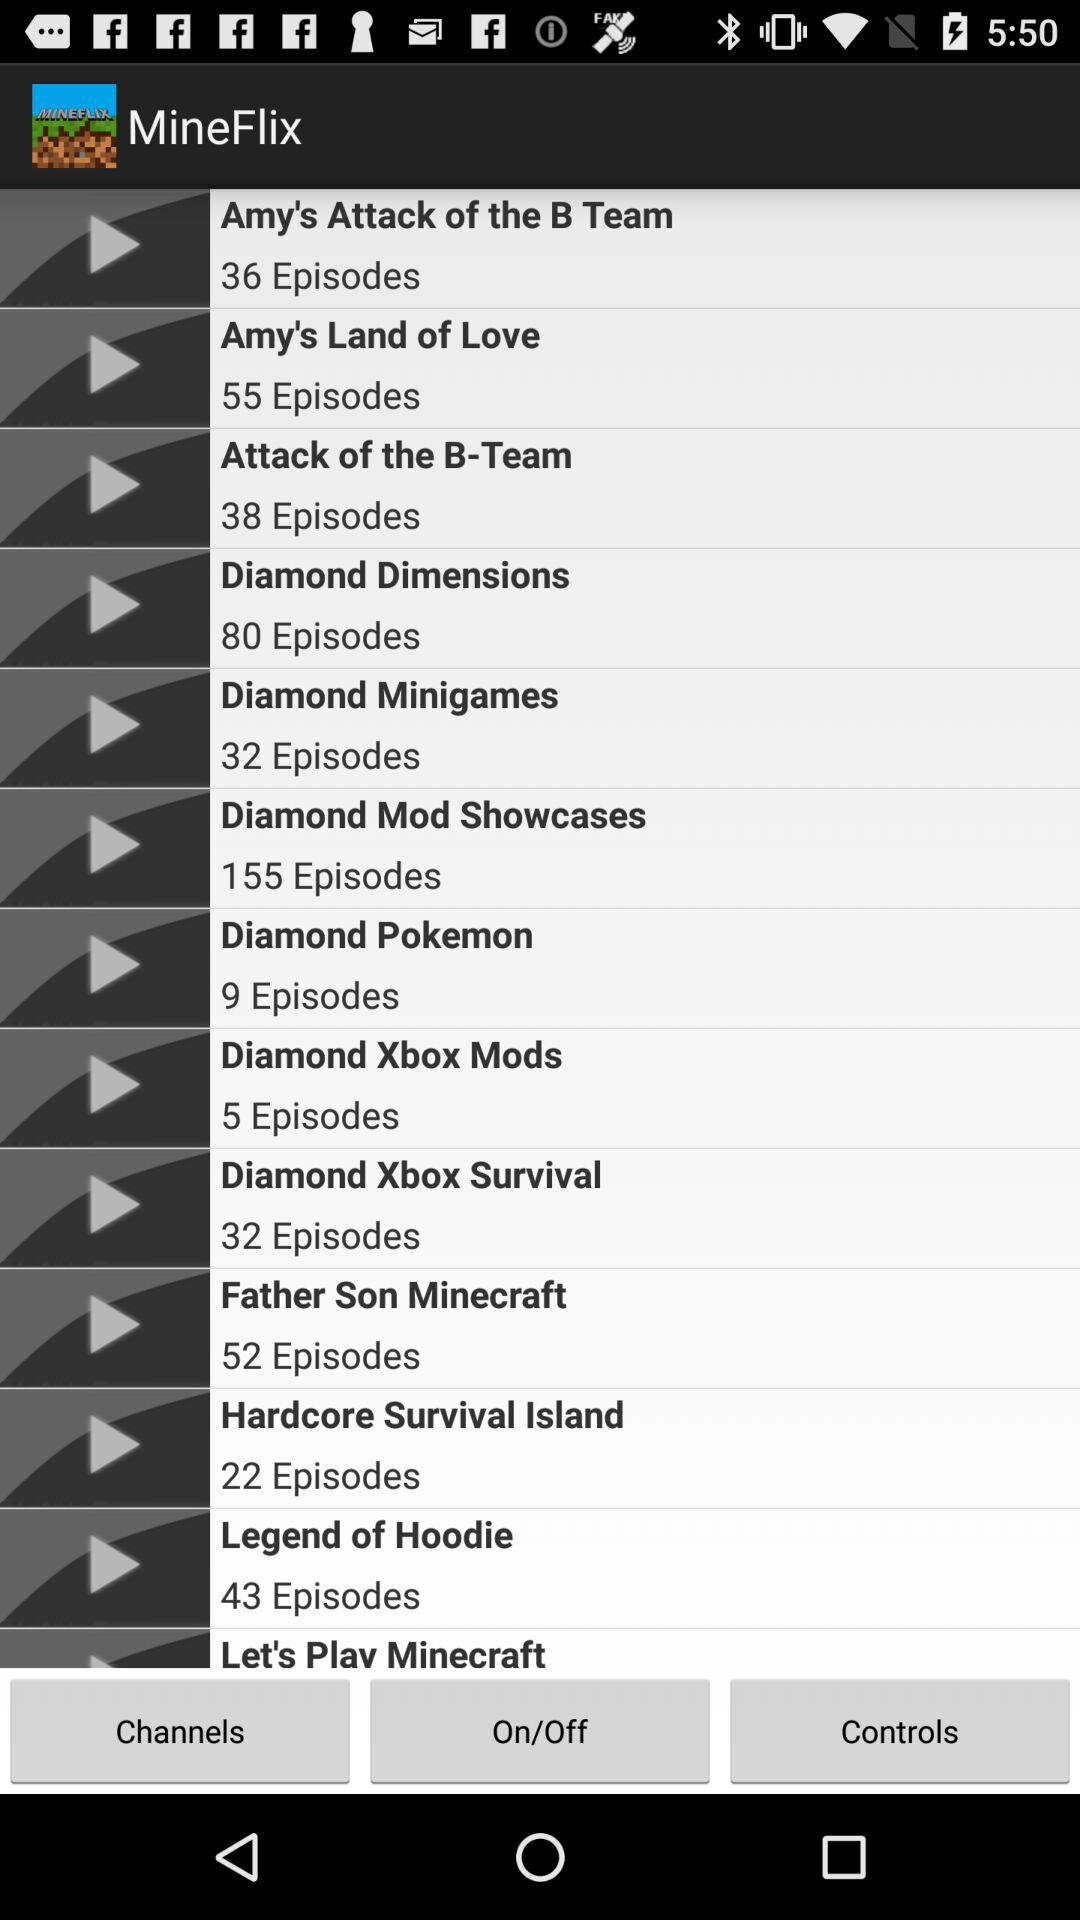Which series has 9 episodes? The series that has 9 episodes is "Diamond Pokemon". 